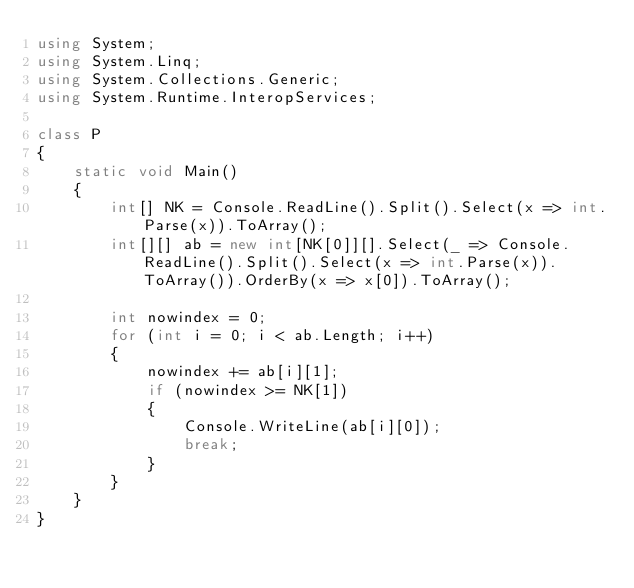<code> <loc_0><loc_0><loc_500><loc_500><_C#_>using System;
using System.Linq;
using System.Collections.Generic;
using System.Runtime.InteropServices;

class P
{
    static void Main()
    {
        int[] NK = Console.ReadLine().Split().Select(x => int.Parse(x)).ToArray();
        int[][] ab = new int[NK[0]][].Select(_ => Console.ReadLine().Split().Select(x => int.Parse(x)).ToArray()).OrderBy(x => x[0]).ToArray();

        int nowindex = 0;
        for (int i = 0; i < ab.Length; i++)
        {
            nowindex += ab[i][1];
            if (nowindex >= NK[1])
            {
                Console.WriteLine(ab[i][0]);
                break;
            }
        }
    }
}</code> 